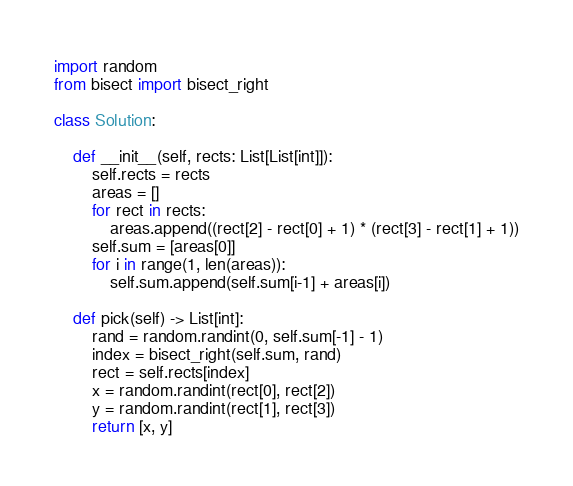<code> <loc_0><loc_0><loc_500><loc_500><_Python_>import random
from bisect import bisect_right

class Solution:

    def __init__(self, rects: List[List[int]]):
        self.rects = rects
        areas = []
        for rect in rects:
            areas.append((rect[2] - rect[0] + 1) * (rect[3] - rect[1] + 1))
        self.sum = [areas[0]]    
        for i in range(1, len(areas)):
            self.sum.append(self.sum[i-1] + areas[i])

    def pick(self) -> List[int]:
        rand = random.randint(0, self.sum[-1] - 1)
        index = bisect_right(self.sum, rand)
        rect = self.rects[index]
        x = random.randint(rect[0], rect[2])
        y = random.randint(rect[1], rect[3])
        return [x, y]
</code> 